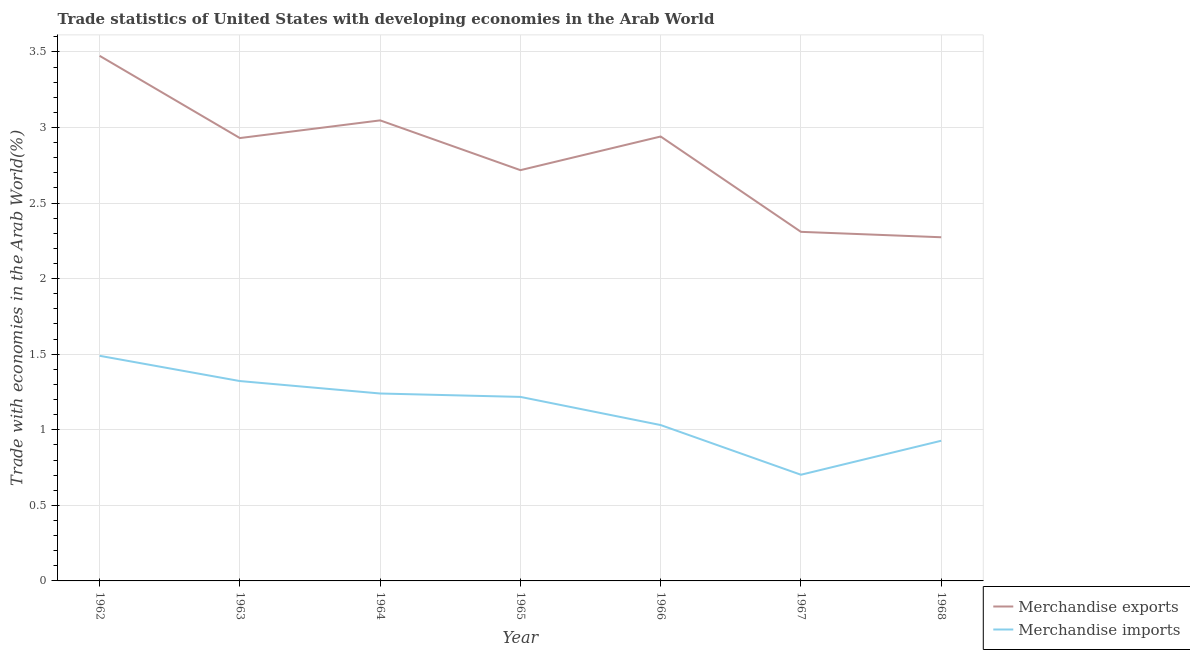Does the line corresponding to merchandise exports intersect with the line corresponding to merchandise imports?
Your answer should be compact. No. Is the number of lines equal to the number of legend labels?
Your response must be concise. Yes. What is the merchandise exports in 1966?
Provide a succinct answer. 2.94. Across all years, what is the maximum merchandise imports?
Give a very brief answer. 1.49. Across all years, what is the minimum merchandise imports?
Offer a terse response. 0.7. In which year was the merchandise exports minimum?
Ensure brevity in your answer.  1968. What is the total merchandise exports in the graph?
Provide a short and direct response. 19.69. What is the difference between the merchandise exports in 1967 and that in 1968?
Give a very brief answer. 0.04. What is the difference between the merchandise exports in 1964 and the merchandise imports in 1967?
Keep it short and to the point. 2.34. What is the average merchandise exports per year?
Offer a terse response. 2.81. In the year 1963, what is the difference between the merchandise imports and merchandise exports?
Keep it short and to the point. -1.61. What is the ratio of the merchandise imports in 1965 to that in 1967?
Offer a terse response. 1.73. What is the difference between the highest and the second highest merchandise imports?
Provide a short and direct response. 0.17. What is the difference between the highest and the lowest merchandise imports?
Keep it short and to the point. 0.79. In how many years, is the merchandise imports greater than the average merchandise imports taken over all years?
Give a very brief answer. 4. Is the sum of the merchandise exports in 1964 and 1967 greater than the maximum merchandise imports across all years?
Offer a terse response. Yes. Does the merchandise exports monotonically increase over the years?
Provide a short and direct response. No. How many years are there in the graph?
Give a very brief answer. 7. What is the difference between two consecutive major ticks on the Y-axis?
Offer a terse response. 0.5. Are the values on the major ticks of Y-axis written in scientific E-notation?
Keep it short and to the point. No. Where does the legend appear in the graph?
Your response must be concise. Bottom right. How are the legend labels stacked?
Your answer should be very brief. Vertical. What is the title of the graph?
Make the answer very short. Trade statistics of United States with developing economies in the Arab World. Does "External balance on goods" appear as one of the legend labels in the graph?
Keep it short and to the point. No. What is the label or title of the Y-axis?
Your answer should be very brief. Trade with economies in the Arab World(%). What is the Trade with economies in the Arab World(%) of Merchandise exports in 1962?
Provide a short and direct response. 3.47. What is the Trade with economies in the Arab World(%) of Merchandise imports in 1962?
Ensure brevity in your answer.  1.49. What is the Trade with economies in the Arab World(%) in Merchandise exports in 1963?
Give a very brief answer. 2.93. What is the Trade with economies in the Arab World(%) of Merchandise imports in 1963?
Keep it short and to the point. 1.32. What is the Trade with economies in the Arab World(%) in Merchandise exports in 1964?
Keep it short and to the point. 3.05. What is the Trade with economies in the Arab World(%) of Merchandise imports in 1964?
Your response must be concise. 1.24. What is the Trade with economies in the Arab World(%) in Merchandise exports in 1965?
Offer a terse response. 2.72. What is the Trade with economies in the Arab World(%) of Merchandise imports in 1965?
Offer a terse response. 1.22. What is the Trade with economies in the Arab World(%) of Merchandise exports in 1966?
Your answer should be very brief. 2.94. What is the Trade with economies in the Arab World(%) in Merchandise imports in 1966?
Your answer should be very brief. 1.03. What is the Trade with economies in the Arab World(%) of Merchandise exports in 1967?
Provide a succinct answer. 2.31. What is the Trade with economies in the Arab World(%) in Merchandise imports in 1967?
Offer a terse response. 0.7. What is the Trade with economies in the Arab World(%) of Merchandise exports in 1968?
Your response must be concise. 2.27. What is the Trade with economies in the Arab World(%) of Merchandise imports in 1968?
Ensure brevity in your answer.  0.93. Across all years, what is the maximum Trade with economies in the Arab World(%) in Merchandise exports?
Provide a succinct answer. 3.47. Across all years, what is the maximum Trade with economies in the Arab World(%) of Merchandise imports?
Provide a short and direct response. 1.49. Across all years, what is the minimum Trade with economies in the Arab World(%) of Merchandise exports?
Provide a succinct answer. 2.27. Across all years, what is the minimum Trade with economies in the Arab World(%) in Merchandise imports?
Provide a succinct answer. 0.7. What is the total Trade with economies in the Arab World(%) in Merchandise exports in the graph?
Offer a very short reply. 19.69. What is the total Trade with economies in the Arab World(%) of Merchandise imports in the graph?
Provide a short and direct response. 7.93. What is the difference between the Trade with economies in the Arab World(%) of Merchandise exports in 1962 and that in 1963?
Give a very brief answer. 0.54. What is the difference between the Trade with economies in the Arab World(%) of Merchandise imports in 1962 and that in 1963?
Ensure brevity in your answer.  0.17. What is the difference between the Trade with economies in the Arab World(%) of Merchandise exports in 1962 and that in 1964?
Your response must be concise. 0.43. What is the difference between the Trade with economies in the Arab World(%) in Merchandise imports in 1962 and that in 1964?
Your answer should be very brief. 0.25. What is the difference between the Trade with economies in the Arab World(%) of Merchandise exports in 1962 and that in 1965?
Offer a very short reply. 0.76. What is the difference between the Trade with economies in the Arab World(%) of Merchandise imports in 1962 and that in 1965?
Your answer should be compact. 0.27. What is the difference between the Trade with economies in the Arab World(%) of Merchandise exports in 1962 and that in 1966?
Give a very brief answer. 0.53. What is the difference between the Trade with economies in the Arab World(%) in Merchandise imports in 1962 and that in 1966?
Your answer should be compact. 0.46. What is the difference between the Trade with economies in the Arab World(%) in Merchandise exports in 1962 and that in 1967?
Your response must be concise. 1.16. What is the difference between the Trade with economies in the Arab World(%) in Merchandise imports in 1962 and that in 1967?
Make the answer very short. 0.79. What is the difference between the Trade with economies in the Arab World(%) of Merchandise exports in 1962 and that in 1968?
Offer a very short reply. 1.2. What is the difference between the Trade with economies in the Arab World(%) of Merchandise imports in 1962 and that in 1968?
Your response must be concise. 0.56. What is the difference between the Trade with economies in the Arab World(%) in Merchandise exports in 1963 and that in 1964?
Ensure brevity in your answer.  -0.12. What is the difference between the Trade with economies in the Arab World(%) in Merchandise imports in 1963 and that in 1964?
Give a very brief answer. 0.08. What is the difference between the Trade with economies in the Arab World(%) of Merchandise exports in 1963 and that in 1965?
Offer a terse response. 0.21. What is the difference between the Trade with economies in the Arab World(%) in Merchandise imports in 1963 and that in 1965?
Give a very brief answer. 0.1. What is the difference between the Trade with economies in the Arab World(%) of Merchandise exports in 1963 and that in 1966?
Your response must be concise. -0.01. What is the difference between the Trade with economies in the Arab World(%) in Merchandise imports in 1963 and that in 1966?
Make the answer very short. 0.29. What is the difference between the Trade with economies in the Arab World(%) in Merchandise exports in 1963 and that in 1967?
Your answer should be compact. 0.62. What is the difference between the Trade with economies in the Arab World(%) in Merchandise imports in 1963 and that in 1967?
Ensure brevity in your answer.  0.62. What is the difference between the Trade with economies in the Arab World(%) in Merchandise exports in 1963 and that in 1968?
Make the answer very short. 0.66. What is the difference between the Trade with economies in the Arab World(%) of Merchandise imports in 1963 and that in 1968?
Your answer should be compact. 0.39. What is the difference between the Trade with economies in the Arab World(%) in Merchandise exports in 1964 and that in 1965?
Offer a very short reply. 0.33. What is the difference between the Trade with economies in the Arab World(%) of Merchandise imports in 1964 and that in 1965?
Your answer should be compact. 0.02. What is the difference between the Trade with economies in the Arab World(%) in Merchandise exports in 1964 and that in 1966?
Provide a succinct answer. 0.11. What is the difference between the Trade with economies in the Arab World(%) of Merchandise imports in 1964 and that in 1966?
Make the answer very short. 0.21. What is the difference between the Trade with economies in the Arab World(%) in Merchandise exports in 1964 and that in 1967?
Offer a terse response. 0.74. What is the difference between the Trade with economies in the Arab World(%) of Merchandise imports in 1964 and that in 1967?
Provide a short and direct response. 0.54. What is the difference between the Trade with economies in the Arab World(%) in Merchandise exports in 1964 and that in 1968?
Your response must be concise. 0.77. What is the difference between the Trade with economies in the Arab World(%) in Merchandise imports in 1964 and that in 1968?
Offer a very short reply. 0.31. What is the difference between the Trade with economies in the Arab World(%) of Merchandise exports in 1965 and that in 1966?
Ensure brevity in your answer.  -0.22. What is the difference between the Trade with economies in the Arab World(%) in Merchandise imports in 1965 and that in 1966?
Give a very brief answer. 0.19. What is the difference between the Trade with economies in the Arab World(%) in Merchandise exports in 1965 and that in 1967?
Give a very brief answer. 0.41. What is the difference between the Trade with economies in the Arab World(%) of Merchandise imports in 1965 and that in 1967?
Make the answer very short. 0.52. What is the difference between the Trade with economies in the Arab World(%) in Merchandise exports in 1965 and that in 1968?
Offer a very short reply. 0.44. What is the difference between the Trade with economies in the Arab World(%) of Merchandise imports in 1965 and that in 1968?
Keep it short and to the point. 0.29. What is the difference between the Trade with economies in the Arab World(%) in Merchandise exports in 1966 and that in 1967?
Make the answer very short. 0.63. What is the difference between the Trade with economies in the Arab World(%) in Merchandise imports in 1966 and that in 1967?
Make the answer very short. 0.33. What is the difference between the Trade with economies in the Arab World(%) in Merchandise exports in 1966 and that in 1968?
Ensure brevity in your answer.  0.67. What is the difference between the Trade with economies in the Arab World(%) in Merchandise imports in 1966 and that in 1968?
Provide a succinct answer. 0.1. What is the difference between the Trade with economies in the Arab World(%) in Merchandise exports in 1967 and that in 1968?
Your answer should be compact. 0.04. What is the difference between the Trade with economies in the Arab World(%) of Merchandise imports in 1967 and that in 1968?
Ensure brevity in your answer.  -0.22. What is the difference between the Trade with economies in the Arab World(%) of Merchandise exports in 1962 and the Trade with economies in the Arab World(%) of Merchandise imports in 1963?
Provide a short and direct response. 2.15. What is the difference between the Trade with economies in the Arab World(%) of Merchandise exports in 1962 and the Trade with economies in the Arab World(%) of Merchandise imports in 1964?
Give a very brief answer. 2.23. What is the difference between the Trade with economies in the Arab World(%) of Merchandise exports in 1962 and the Trade with economies in the Arab World(%) of Merchandise imports in 1965?
Ensure brevity in your answer.  2.26. What is the difference between the Trade with economies in the Arab World(%) of Merchandise exports in 1962 and the Trade with economies in the Arab World(%) of Merchandise imports in 1966?
Your response must be concise. 2.44. What is the difference between the Trade with economies in the Arab World(%) of Merchandise exports in 1962 and the Trade with economies in the Arab World(%) of Merchandise imports in 1967?
Provide a short and direct response. 2.77. What is the difference between the Trade with economies in the Arab World(%) in Merchandise exports in 1962 and the Trade with economies in the Arab World(%) in Merchandise imports in 1968?
Your answer should be compact. 2.55. What is the difference between the Trade with economies in the Arab World(%) of Merchandise exports in 1963 and the Trade with economies in the Arab World(%) of Merchandise imports in 1964?
Your response must be concise. 1.69. What is the difference between the Trade with economies in the Arab World(%) in Merchandise exports in 1963 and the Trade with economies in the Arab World(%) in Merchandise imports in 1965?
Ensure brevity in your answer.  1.71. What is the difference between the Trade with economies in the Arab World(%) in Merchandise exports in 1963 and the Trade with economies in the Arab World(%) in Merchandise imports in 1966?
Keep it short and to the point. 1.9. What is the difference between the Trade with economies in the Arab World(%) of Merchandise exports in 1963 and the Trade with economies in the Arab World(%) of Merchandise imports in 1967?
Ensure brevity in your answer.  2.23. What is the difference between the Trade with economies in the Arab World(%) in Merchandise exports in 1963 and the Trade with economies in the Arab World(%) in Merchandise imports in 1968?
Offer a very short reply. 2. What is the difference between the Trade with economies in the Arab World(%) in Merchandise exports in 1964 and the Trade with economies in the Arab World(%) in Merchandise imports in 1965?
Ensure brevity in your answer.  1.83. What is the difference between the Trade with economies in the Arab World(%) of Merchandise exports in 1964 and the Trade with economies in the Arab World(%) of Merchandise imports in 1966?
Your answer should be compact. 2.02. What is the difference between the Trade with economies in the Arab World(%) of Merchandise exports in 1964 and the Trade with economies in the Arab World(%) of Merchandise imports in 1967?
Your answer should be compact. 2.34. What is the difference between the Trade with economies in the Arab World(%) in Merchandise exports in 1964 and the Trade with economies in the Arab World(%) in Merchandise imports in 1968?
Provide a short and direct response. 2.12. What is the difference between the Trade with economies in the Arab World(%) of Merchandise exports in 1965 and the Trade with economies in the Arab World(%) of Merchandise imports in 1966?
Offer a very short reply. 1.69. What is the difference between the Trade with economies in the Arab World(%) in Merchandise exports in 1965 and the Trade with economies in the Arab World(%) in Merchandise imports in 1967?
Offer a terse response. 2.02. What is the difference between the Trade with economies in the Arab World(%) in Merchandise exports in 1965 and the Trade with economies in the Arab World(%) in Merchandise imports in 1968?
Make the answer very short. 1.79. What is the difference between the Trade with economies in the Arab World(%) in Merchandise exports in 1966 and the Trade with economies in the Arab World(%) in Merchandise imports in 1967?
Keep it short and to the point. 2.24. What is the difference between the Trade with economies in the Arab World(%) of Merchandise exports in 1966 and the Trade with economies in the Arab World(%) of Merchandise imports in 1968?
Ensure brevity in your answer.  2.01. What is the difference between the Trade with economies in the Arab World(%) in Merchandise exports in 1967 and the Trade with economies in the Arab World(%) in Merchandise imports in 1968?
Ensure brevity in your answer.  1.38. What is the average Trade with economies in the Arab World(%) of Merchandise exports per year?
Make the answer very short. 2.81. What is the average Trade with economies in the Arab World(%) of Merchandise imports per year?
Your answer should be very brief. 1.13. In the year 1962, what is the difference between the Trade with economies in the Arab World(%) in Merchandise exports and Trade with economies in the Arab World(%) in Merchandise imports?
Provide a short and direct response. 1.98. In the year 1963, what is the difference between the Trade with economies in the Arab World(%) of Merchandise exports and Trade with economies in the Arab World(%) of Merchandise imports?
Give a very brief answer. 1.61. In the year 1964, what is the difference between the Trade with economies in the Arab World(%) in Merchandise exports and Trade with economies in the Arab World(%) in Merchandise imports?
Offer a terse response. 1.81. In the year 1965, what is the difference between the Trade with economies in the Arab World(%) in Merchandise exports and Trade with economies in the Arab World(%) in Merchandise imports?
Keep it short and to the point. 1.5. In the year 1966, what is the difference between the Trade with economies in the Arab World(%) of Merchandise exports and Trade with economies in the Arab World(%) of Merchandise imports?
Ensure brevity in your answer.  1.91. In the year 1967, what is the difference between the Trade with economies in the Arab World(%) in Merchandise exports and Trade with economies in the Arab World(%) in Merchandise imports?
Give a very brief answer. 1.61. In the year 1968, what is the difference between the Trade with economies in the Arab World(%) in Merchandise exports and Trade with economies in the Arab World(%) in Merchandise imports?
Provide a succinct answer. 1.35. What is the ratio of the Trade with economies in the Arab World(%) of Merchandise exports in 1962 to that in 1963?
Provide a short and direct response. 1.19. What is the ratio of the Trade with economies in the Arab World(%) of Merchandise imports in 1962 to that in 1963?
Keep it short and to the point. 1.13. What is the ratio of the Trade with economies in the Arab World(%) in Merchandise exports in 1962 to that in 1964?
Give a very brief answer. 1.14. What is the ratio of the Trade with economies in the Arab World(%) in Merchandise imports in 1962 to that in 1964?
Give a very brief answer. 1.2. What is the ratio of the Trade with economies in the Arab World(%) of Merchandise exports in 1962 to that in 1965?
Make the answer very short. 1.28. What is the ratio of the Trade with economies in the Arab World(%) in Merchandise imports in 1962 to that in 1965?
Your answer should be very brief. 1.22. What is the ratio of the Trade with economies in the Arab World(%) in Merchandise exports in 1962 to that in 1966?
Your response must be concise. 1.18. What is the ratio of the Trade with economies in the Arab World(%) in Merchandise imports in 1962 to that in 1966?
Give a very brief answer. 1.44. What is the ratio of the Trade with economies in the Arab World(%) of Merchandise exports in 1962 to that in 1967?
Keep it short and to the point. 1.5. What is the ratio of the Trade with economies in the Arab World(%) in Merchandise imports in 1962 to that in 1967?
Offer a very short reply. 2.12. What is the ratio of the Trade with economies in the Arab World(%) of Merchandise exports in 1962 to that in 1968?
Make the answer very short. 1.53. What is the ratio of the Trade with economies in the Arab World(%) in Merchandise imports in 1962 to that in 1968?
Give a very brief answer. 1.61. What is the ratio of the Trade with economies in the Arab World(%) of Merchandise exports in 1963 to that in 1964?
Offer a terse response. 0.96. What is the ratio of the Trade with economies in the Arab World(%) of Merchandise imports in 1963 to that in 1964?
Provide a short and direct response. 1.07. What is the ratio of the Trade with economies in the Arab World(%) of Merchandise exports in 1963 to that in 1965?
Your response must be concise. 1.08. What is the ratio of the Trade with economies in the Arab World(%) in Merchandise imports in 1963 to that in 1965?
Ensure brevity in your answer.  1.09. What is the ratio of the Trade with economies in the Arab World(%) of Merchandise exports in 1963 to that in 1966?
Provide a short and direct response. 1. What is the ratio of the Trade with economies in the Arab World(%) in Merchandise imports in 1963 to that in 1966?
Your response must be concise. 1.28. What is the ratio of the Trade with economies in the Arab World(%) in Merchandise exports in 1963 to that in 1967?
Give a very brief answer. 1.27. What is the ratio of the Trade with economies in the Arab World(%) of Merchandise imports in 1963 to that in 1967?
Your answer should be compact. 1.88. What is the ratio of the Trade with economies in the Arab World(%) in Merchandise exports in 1963 to that in 1968?
Your answer should be compact. 1.29. What is the ratio of the Trade with economies in the Arab World(%) in Merchandise imports in 1963 to that in 1968?
Provide a succinct answer. 1.43. What is the ratio of the Trade with economies in the Arab World(%) of Merchandise exports in 1964 to that in 1965?
Offer a terse response. 1.12. What is the ratio of the Trade with economies in the Arab World(%) of Merchandise imports in 1964 to that in 1965?
Give a very brief answer. 1.02. What is the ratio of the Trade with economies in the Arab World(%) in Merchandise exports in 1964 to that in 1966?
Give a very brief answer. 1.04. What is the ratio of the Trade with economies in the Arab World(%) in Merchandise imports in 1964 to that in 1966?
Give a very brief answer. 1.2. What is the ratio of the Trade with economies in the Arab World(%) in Merchandise exports in 1964 to that in 1967?
Offer a very short reply. 1.32. What is the ratio of the Trade with economies in the Arab World(%) in Merchandise imports in 1964 to that in 1967?
Provide a succinct answer. 1.77. What is the ratio of the Trade with economies in the Arab World(%) in Merchandise exports in 1964 to that in 1968?
Your answer should be very brief. 1.34. What is the ratio of the Trade with economies in the Arab World(%) in Merchandise imports in 1964 to that in 1968?
Offer a very short reply. 1.34. What is the ratio of the Trade with economies in the Arab World(%) of Merchandise exports in 1965 to that in 1966?
Offer a terse response. 0.92. What is the ratio of the Trade with economies in the Arab World(%) in Merchandise imports in 1965 to that in 1966?
Make the answer very short. 1.18. What is the ratio of the Trade with economies in the Arab World(%) in Merchandise exports in 1965 to that in 1967?
Ensure brevity in your answer.  1.18. What is the ratio of the Trade with economies in the Arab World(%) of Merchandise imports in 1965 to that in 1967?
Your response must be concise. 1.73. What is the ratio of the Trade with economies in the Arab World(%) of Merchandise exports in 1965 to that in 1968?
Provide a short and direct response. 1.2. What is the ratio of the Trade with economies in the Arab World(%) of Merchandise imports in 1965 to that in 1968?
Offer a very short reply. 1.31. What is the ratio of the Trade with economies in the Arab World(%) of Merchandise exports in 1966 to that in 1967?
Your answer should be compact. 1.27. What is the ratio of the Trade with economies in the Arab World(%) of Merchandise imports in 1966 to that in 1967?
Provide a succinct answer. 1.47. What is the ratio of the Trade with economies in the Arab World(%) of Merchandise exports in 1966 to that in 1968?
Your answer should be compact. 1.29. What is the ratio of the Trade with economies in the Arab World(%) of Merchandise imports in 1966 to that in 1968?
Ensure brevity in your answer.  1.11. What is the ratio of the Trade with economies in the Arab World(%) of Merchandise exports in 1967 to that in 1968?
Ensure brevity in your answer.  1.02. What is the ratio of the Trade with economies in the Arab World(%) in Merchandise imports in 1967 to that in 1968?
Offer a terse response. 0.76. What is the difference between the highest and the second highest Trade with economies in the Arab World(%) of Merchandise exports?
Provide a succinct answer. 0.43. What is the difference between the highest and the second highest Trade with economies in the Arab World(%) of Merchandise imports?
Your response must be concise. 0.17. What is the difference between the highest and the lowest Trade with economies in the Arab World(%) of Merchandise exports?
Provide a short and direct response. 1.2. What is the difference between the highest and the lowest Trade with economies in the Arab World(%) of Merchandise imports?
Provide a short and direct response. 0.79. 